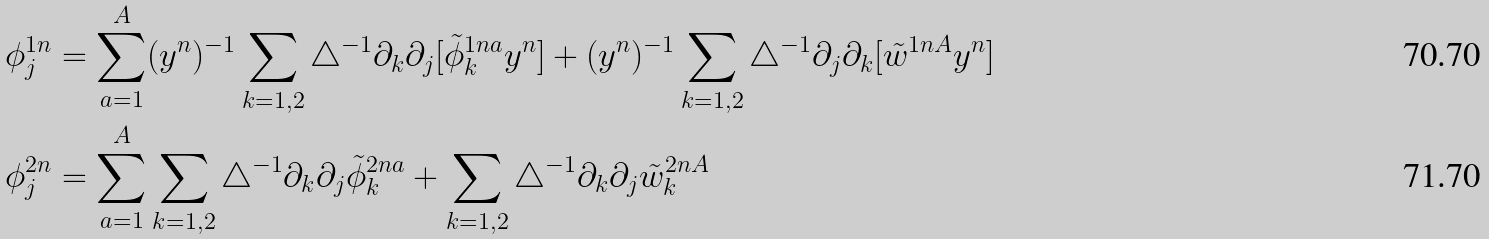<formula> <loc_0><loc_0><loc_500><loc_500>\phi ^ { 1 n } _ { j } & = \sum _ { a = 1 } ^ { A } ( { y } ^ { n } ) ^ { - 1 } \sum _ { k = 1 , 2 } \triangle ^ { - 1 } \partial _ { k } \partial _ { j } [ \tilde { \phi } ^ { 1 n a } _ { k } { y } ^ { n } ] + ( { y } ^ { n } ) ^ { - 1 } \sum _ { k = 1 , 2 } \triangle ^ { - 1 } \partial _ { j } \partial _ { k } [ \tilde { w } ^ { 1 n A } { y } ^ { n } ] \\ \phi ^ { 2 n } _ { j } & = \sum _ { a = 1 } ^ { A } \sum _ { k = 1 , 2 } \triangle ^ { - 1 } \partial _ { k } \partial _ { j } \tilde { \phi } ^ { 2 n a } _ { k } + \sum _ { k = 1 , 2 } \triangle ^ { - 1 } \partial _ { k } \partial _ { j } \tilde { w } ^ { 2 n A } _ { k }</formula> 